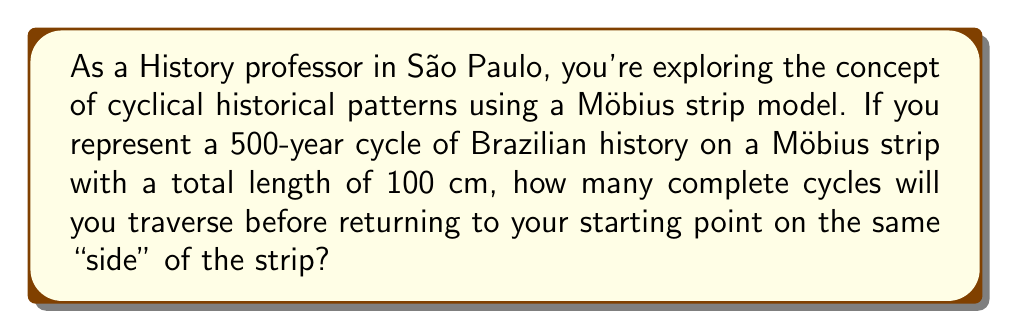Give your solution to this math problem. To solve this problem, we need to understand the unique properties of a Möbius strip and how it relates to historical cycles:

1) A Möbius strip is a surface with only one side and one edge. It's created by taking a strip of paper, giving it a half-twist, and then joining the ends.

2) When tracing a line on a Möbius strip, you will return to the starting point after traversing twice the length of the strip.

3) In this case, one complete historical cycle (500 years) is represented by the full length of the strip (100 cm).

4) To calculate the number of cycles before returning to the starting point on the same "side":

   $$\text{Number of cycles} = \frac{\text{Distance to return to start on same side}}{\text{Length of one cycle}}$$

5) The distance to return to the start on the same side is twice the length of the strip:
   $$\text{Distance} = 2 \times 100 \text{ cm} = 200 \text{ cm}$$

6) Therefore:
   $$\text{Number of cycles} = \frac{200 \text{ cm}}{100 \text{ cm}} = 2$$

This means you will traverse 2 complete 500-year cycles (1000 years total) before returning to the starting point on the same "side" of the Möbius strip.

[asy]
import geometry;

pair A=(0,0), B=(100,0), C=(100,20), D=(0,20);
path p=A--B--C--D--cycle;
fill(p,lightgray);
draw(p);
draw((0,10)--(100,10),dashed);
label("Start/End",(-5,10),W);
draw(arc((50,10),10,0,180),Arrow);
draw(arc((50,10),10,180,360),Arrow);
label("500 years",(50,25),N);
label("500 years",(50,-5),S);
</asy]

This diagram illustrates the Möbius strip representation of the historical cycle. The arrows indicate the direction of time, and you can see that after two complete revolutions, you return to the starting point on the same "side" of the strip.
Answer: 2 complete cycles 